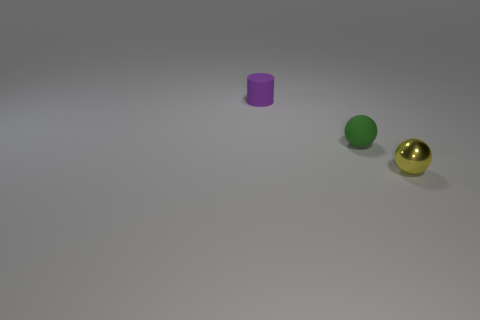There is a matte thing that is on the right side of the rubber cylinder; is it the same size as the small metallic sphere?
Offer a very short reply. Yes. Are there any other things that have the same color as the matte cylinder?
Your response must be concise. No. What is the shape of the purple thing?
Provide a short and direct response. Cylinder. What number of tiny objects are right of the tiny purple rubber cylinder and behind the tiny matte sphere?
Give a very brief answer. 0. Does the shiny object have the same color as the cylinder?
Your answer should be compact. No. There is another tiny object that is the same shape as the tiny green rubber object; what is it made of?
Keep it short and to the point. Metal. Are there any other things that are the same material as the tiny cylinder?
Ensure brevity in your answer.  Yes. Are there an equal number of small cylinders to the right of the tiny green rubber sphere and matte things on the right side of the tiny metallic thing?
Provide a succinct answer. Yes. Do the small yellow thing and the small cylinder have the same material?
Your response must be concise. No. How many yellow things are either metal spheres or large metallic things?
Provide a succinct answer. 1. 